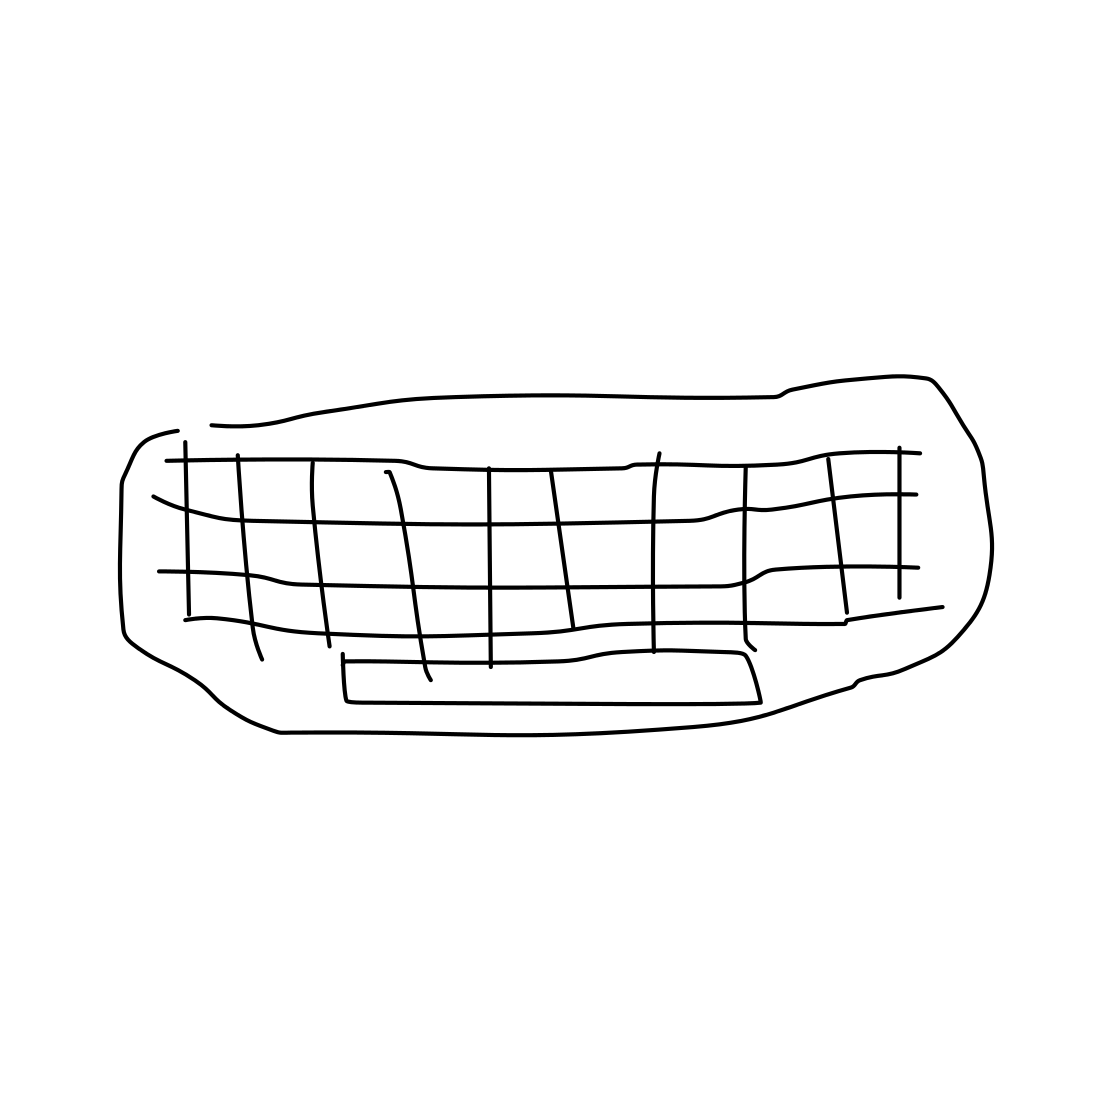Is there a sketchy ear in the picture? No 